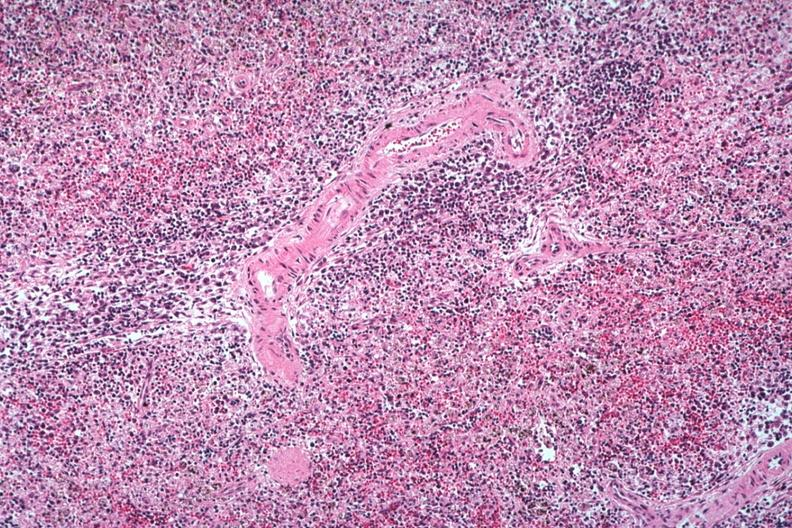what died of viral pneumonia likely to have been influenzae?
Answer the question using a single word or phrase. Well seen atypical cells surrounding splenic arteriole man 